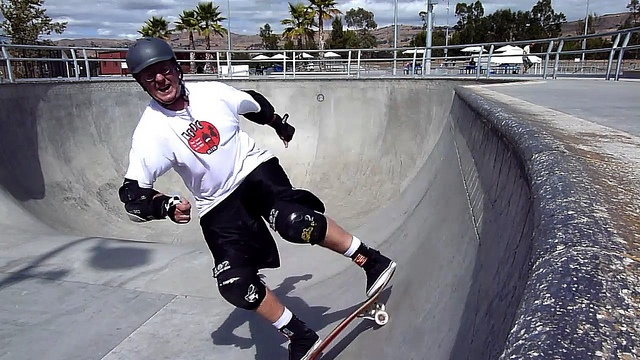Describe the objects in this image and their specific colors. I can see people in darkgray, black, white, and gray tones, skateboard in darkgray, black, white, and gray tones, people in darkgray, black, gray, and white tones, bench in darkgray, black, navy, and gray tones, and umbrella in darkgray, white, black, and gray tones in this image. 